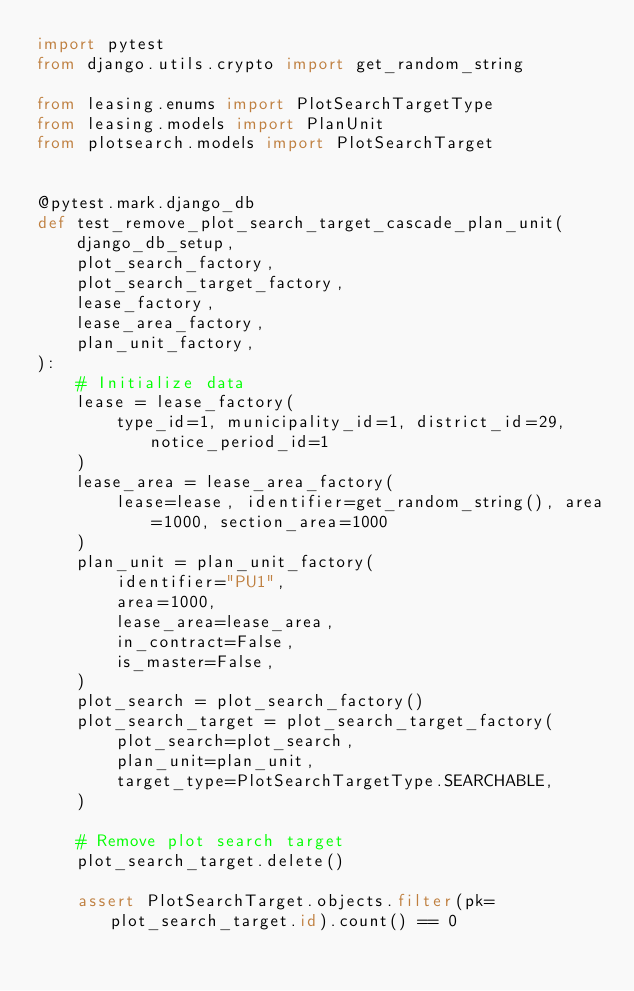Convert code to text. <code><loc_0><loc_0><loc_500><loc_500><_Python_>import pytest
from django.utils.crypto import get_random_string

from leasing.enums import PlotSearchTargetType
from leasing.models import PlanUnit
from plotsearch.models import PlotSearchTarget


@pytest.mark.django_db
def test_remove_plot_search_target_cascade_plan_unit(
    django_db_setup,
    plot_search_factory,
    plot_search_target_factory,
    lease_factory,
    lease_area_factory,
    plan_unit_factory,
):
    # Initialize data
    lease = lease_factory(
        type_id=1, municipality_id=1, district_id=29, notice_period_id=1
    )
    lease_area = lease_area_factory(
        lease=lease, identifier=get_random_string(), area=1000, section_area=1000
    )
    plan_unit = plan_unit_factory(
        identifier="PU1",
        area=1000,
        lease_area=lease_area,
        in_contract=False,
        is_master=False,
    )
    plot_search = plot_search_factory()
    plot_search_target = plot_search_target_factory(
        plot_search=plot_search,
        plan_unit=plan_unit,
        target_type=PlotSearchTargetType.SEARCHABLE,
    )

    # Remove plot search target
    plot_search_target.delete()

    assert PlotSearchTarget.objects.filter(pk=plot_search_target.id).count() == 0</code> 